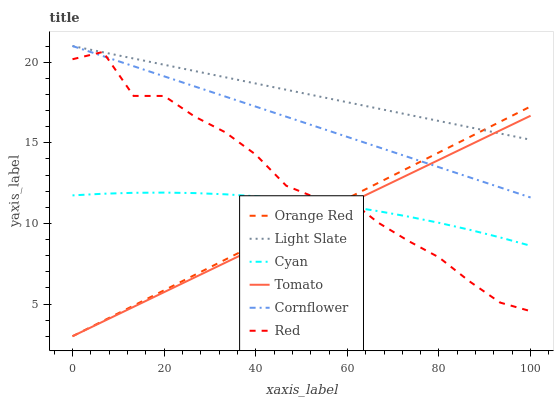Does Tomato have the minimum area under the curve?
Answer yes or no. Yes. Does Light Slate have the maximum area under the curve?
Answer yes or no. Yes. Does Cornflower have the minimum area under the curve?
Answer yes or no. No. Does Cornflower have the maximum area under the curve?
Answer yes or no. No. Is Tomato the smoothest?
Answer yes or no. Yes. Is Red the roughest?
Answer yes or no. Yes. Is Cornflower the smoothest?
Answer yes or no. No. Is Cornflower the roughest?
Answer yes or no. No. Does Tomato have the lowest value?
Answer yes or no. Yes. Does Cornflower have the lowest value?
Answer yes or no. No. Does Light Slate have the highest value?
Answer yes or no. Yes. Does Cyan have the highest value?
Answer yes or no. No. Is Cyan less than Light Slate?
Answer yes or no. Yes. Is Light Slate greater than Cyan?
Answer yes or no. Yes. Does Tomato intersect Light Slate?
Answer yes or no. Yes. Is Tomato less than Light Slate?
Answer yes or no. No. Is Tomato greater than Light Slate?
Answer yes or no. No. Does Cyan intersect Light Slate?
Answer yes or no. No. 